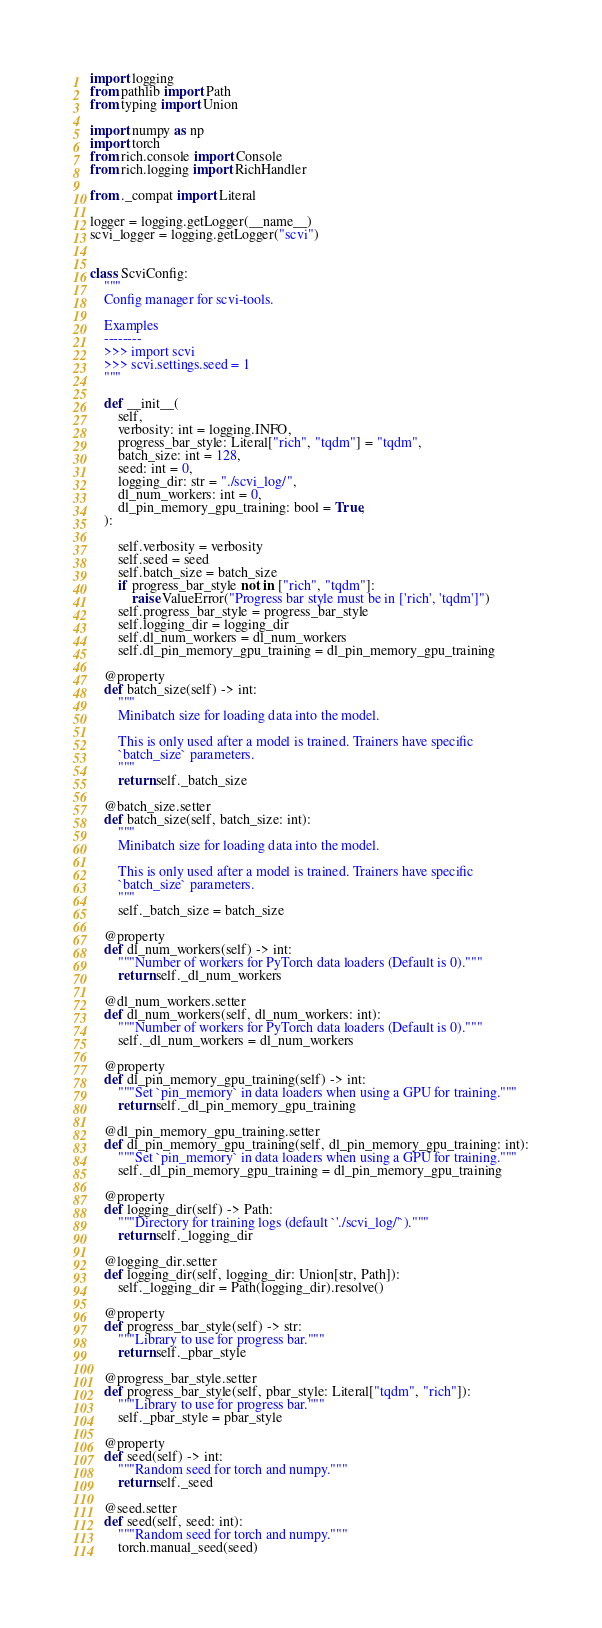<code> <loc_0><loc_0><loc_500><loc_500><_Python_>import logging
from pathlib import Path
from typing import Union

import numpy as np
import torch
from rich.console import Console
from rich.logging import RichHandler

from ._compat import Literal

logger = logging.getLogger(__name__)
scvi_logger = logging.getLogger("scvi")


class ScviConfig:
    """
    Config manager for scvi-tools.

    Examples
    --------
    >>> import scvi
    >>> scvi.settings.seed = 1
    """

    def __init__(
        self,
        verbosity: int = logging.INFO,
        progress_bar_style: Literal["rich", "tqdm"] = "tqdm",
        batch_size: int = 128,
        seed: int = 0,
        logging_dir: str = "./scvi_log/",
        dl_num_workers: int = 0,
        dl_pin_memory_gpu_training: bool = True,
    ):

        self.verbosity = verbosity
        self.seed = seed
        self.batch_size = batch_size
        if progress_bar_style not in ["rich", "tqdm"]:
            raise ValueError("Progress bar style must be in ['rich', 'tqdm']")
        self.progress_bar_style = progress_bar_style
        self.logging_dir = logging_dir
        self.dl_num_workers = dl_num_workers
        self.dl_pin_memory_gpu_training = dl_pin_memory_gpu_training

    @property
    def batch_size(self) -> int:
        """
        Minibatch size for loading data into the model.

        This is only used after a model is trained. Trainers have specific
        `batch_size` parameters.
        """
        return self._batch_size

    @batch_size.setter
    def batch_size(self, batch_size: int):
        """
        Minibatch size for loading data into the model.

        This is only used after a model is trained. Trainers have specific
        `batch_size` parameters.
        """
        self._batch_size = batch_size

    @property
    def dl_num_workers(self) -> int:
        """Number of workers for PyTorch data loaders (Default is 0)."""
        return self._dl_num_workers

    @dl_num_workers.setter
    def dl_num_workers(self, dl_num_workers: int):
        """Number of workers for PyTorch data loaders (Default is 0)."""
        self._dl_num_workers = dl_num_workers

    @property
    def dl_pin_memory_gpu_training(self) -> int:
        """Set `pin_memory` in data loaders when using a GPU for training."""
        return self._dl_pin_memory_gpu_training

    @dl_pin_memory_gpu_training.setter
    def dl_pin_memory_gpu_training(self, dl_pin_memory_gpu_training: int):
        """Set `pin_memory` in data loaders when using a GPU for training."""
        self._dl_pin_memory_gpu_training = dl_pin_memory_gpu_training

    @property
    def logging_dir(self) -> Path:
        """Directory for training logs (default `'./scvi_log/'`)."""
        return self._logging_dir

    @logging_dir.setter
    def logging_dir(self, logging_dir: Union[str, Path]):
        self._logging_dir = Path(logging_dir).resolve()

    @property
    def progress_bar_style(self) -> str:
        """Library to use for progress bar."""
        return self._pbar_style

    @progress_bar_style.setter
    def progress_bar_style(self, pbar_style: Literal["tqdm", "rich"]):
        """Library to use for progress bar."""
        self._pbar_style = pbar_style

    @property
    def seed(self) -> int:
        """Random seed for torch and numpy."""
        return self._seed

    @seed.setter
    def seed(self, seed: int):
        """Random seed for torch and numpy."""
        torch.manual_seed(seed)</code> 